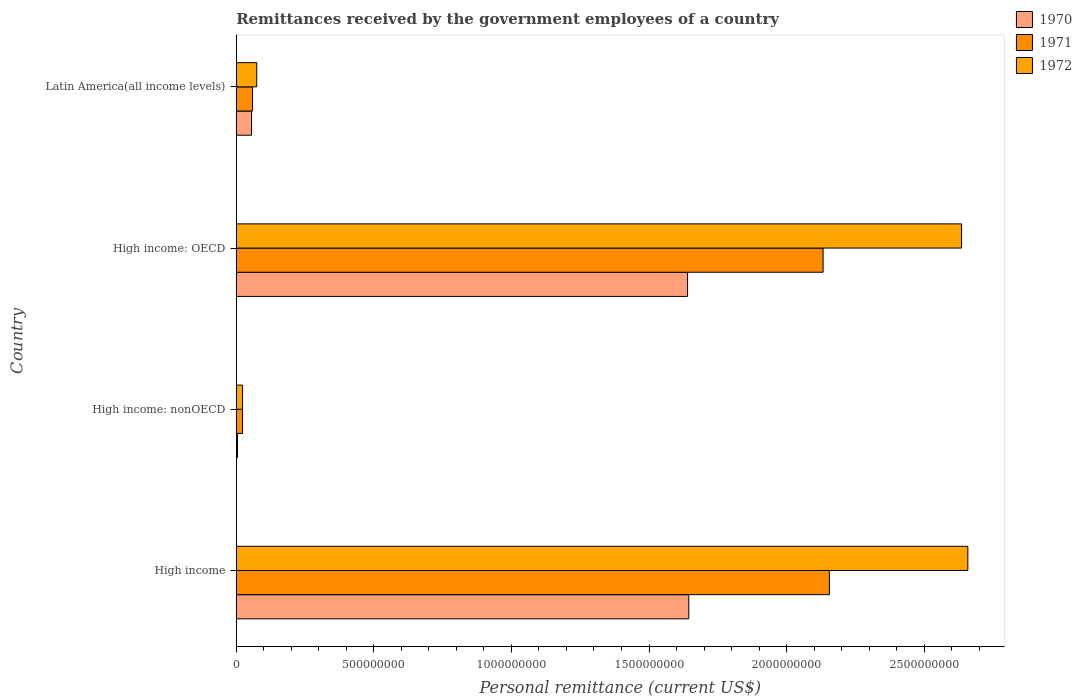How many different coloured bars are there?
Make the answer very short. 3. What is the label of the 2nd group of bars from the top?
Make the answer very short. High income: OECD. In how many cases, is the number of bars for a given country not equal to the number of legend labels?
Offer a terse response. 0. What is the remittances received by the government employees in 1972 in High income: OECD?
Ensure brevity in your answer.  2.64e+09. Across all countries, what is the maximum remittances received by the government employees in 1971?
Your answer should be compact. 2.16e+09. Across all countries, what is the minimum remittances received by the government employees in 1970?
Your answer should be compact. 4.40e+06. In which country was the remittances received by the government employees in 1970 maximum?
Your response must be concise. High income. In which country was the remittances received by the government employees in 1970 minimum?
Your answer should be compact. High income: nonOECD. What is the total remittances received by the government employees in 1970 in the graph?
Offer a very short reply. 3.34e+09. What is the difference between the remittances received by the government employees in 1971 in High income: OECD and that in High income: nonOECD?
Keep it short and to the point. 2.11e+09. What is the difference between the remittances received by the government employees in 1971 in High income and the remittances received by the government employees in 1972 in High income: nonOECD?
Offer a very short reply. 2.13e+09. What is the average remittances received by the government employees in 1972 per country?
Your answer should be very brief. 1.35e+09. What is the difference between the remittances received by the government employees in 1971 and remittances received by the government employees in 1972 in Latin America(all income levels)?
Your response must be concise. -1.54e+07. In how many countries, is the remittances received by the government employees in 1970 greater than 1400000000 US$?
Offer a terse response. 2. What is the ratio of the remittances received by the government employees in 1972 in High income to that in Latin America(all income levels)?
Your answer should be compact. 35.7. Is the remittances received by the government employees in 1970 in High income: nonOECD less than that in Latin America(all income levels)?
Give a very brief answer. Yes. What is the difference between the highest and the second highest remittances received by the government employees in 1970?
Your answer should be compact. 4.40e+06. What is the difference between the highest and the lowest remittances received by the government employees in 1971?
Give a very brief answer. 2.13e+09. Is the sum of the remittances received by the government employees in 1972 in High income and Latin America(all income levels) greater than the maximum remittances received by the government employees in 1971 across all countries?
Your response must be concise. Yes. Are all the bars in the graph horizontal?
Your response must be concise. Yes. How many countries are there in the graph?
Your response must be concise. 4. Are the values on the major ticks of X-axis written in scientific E-notation?
Provide a succinct answer. No. Where does the legend appear in the graph?
Give a very brief answer. Top right. How many legend labels are there?
Provide a short and direct response. 3. What is the title of the graph?
Your answer should be very brief. Remittances received by the government employees of a country. What is the label or title of the X-axis?
Your answer should be very brief. Personal remittance (current US$). What is the label or title of the Y-axis?
Make the answer very short. Country. What is the Personal remittance (current US$) of 1970 in High income?
Ensure brevity in your answer.  1.64e+09. What is the Personal remittance (current US$) of 1971 in High income?
Make the answer very short. 2.16e+09. What is the Personal remittance (current US$) in 1972 in High income?
Your answer should be compact. 2.66e+09. What is the Personal remittance (current US$) in 1970 in High income: nonOECD?
Your answer should be very brief. 4.40e+06. What is the Personal remittance (current US$) in 1971 in High income: nonOECD?
Keep it short and to the point. 2.28e+07. What is the Personal remittance (current US$) in 1972 in High income: nonOECD?
Your answer should be compact. 2.29e+07. What is the Personal remittance (current US$) in 1970 in High income: OECD?
Your response must be concise. 1.64e+09. What is the Personal remittance (current US$) of 1971 in High income: OECD?
Offer a very short reply. 2.13e+09. What is the Personal remittance (current US$) in 1972 in High income: OECD?
Ensure brevity in your answer.  2.64e+09. What is the Personal remittance (current US$) of 1970 in Latin America(all income levels)?
Give a very brief answer. 5.55e+07. What is the Personal remittance (current US$) in 1971 in Latin America(all income levels)?
Your answer should be very brief. 5.91e+07. What is the Personal remittance (current US$) of 1972 in Latin America(all income levels)?
Offer a terse response. 7.45e+07. Across all countries, what is the maximum Personal remittance (current US$) in 1970?
Your answer should be very brief. 1.64e+09. Across all countries, what is the maximum Personal remittance (current US$) of 1971?
Provide a short and direct response. 2.16e+09. Across all countries, what is the maximum Personal remittance (current US$) in 1972?
Offer a very short reply. 2.66e+09. Across all countries, what is the minimum Personal remittance (current US$) of 1970?
Your answer should be very brief. 4.40e+06. Across all countries, what is the minimum Personal remittance (current US$) in 1971?
Ensure brevity in your answer.  2.28e+07. Across all countries, what is the minimum Personal remittance (current US$) in 1972?
Ensure brevity in your answer.  2.29e+07. What is the total Personal remittance (current US$) in 1970 in the graph?
Ensure brevity in your answer.  3.34e+09. What is the total Personal remittance (current US$) in 1971 in the graph?
Your response must be concise. 4.37e+09. What is the total Personal remittance (current US$) in 1972 in the graph?
Offer a terse response. 5.39e+09. What is the difference between the Personal remittance (current US$) in 1970 in High income and that in High income: nonOECD?
Ensure brevity in your answer.  1.64e+09. What is the difference between the Personal remittance (current US$) in 1971 in High income and that in High income: nonOECD?
Make the answer very short. 2.13e+09. What is the difference between the Personal remittance (current US$) in 1972 in High income and that in High income: nonOECD?
Provide a short and direct response. 2.64e+09. What is the difference between the Personal remittance (current US$) of 1970 in High income and that in High income: OECD?
Make the answer very short. 4.40e+06. What is the difference between the Personal remittance (current US$) of 1971 in High income and that in High income: OECD?
Offer a very short reply. 2.28e+07. What is the difference between the Personal remittance (current US$) in 1972 in High income and that in High income: OECD?
Your response must be concise. 2.29e+07. What is the difference between the Personal remittance (current US$) in 1970 in High income and that in Latin America(all income levels)?
Ensure brevity in your answer.  1.59e+09. What is the difference between the Personal remittance (current US$) of 1971 in High income and that in Latin America(all income levels)?
Offer a very short reply. 2.10e+09. What is the difference between the Personal remittance (current US$) in 1972 in High income and that in Latin America(all income levels)?
Provide a short and direct response. 2.58e+09. What is the difference between the Personal remittance (current US$) in 1970 in High income: nonOECD and that in High income: OECD?
Make the answer very short. -1.64e+09. What is the difference between the Personal remittance (current US$) in 1971 in High income: nonOECD and that in High income: OECD?
Make the answer very short. -2.11e+09. What is the difference between the Personal remittance (current US$) in 1972 in High income: nonOECD and that in High income: OECD?
Your response must be concise. -2.61e+09. What is the difference between the Personal remittance (current US$) of 1970 in High income: nonOECD and that in Latin America(all income levels)?
Provide a short and direct response. -5.11e+07. What is the difference between the Personal remittance (current US$) of 1971 in High income: nonOECD and that in Latin America(all income levels)?
Provide a short and direct response. -3.63e+07. What is the difference between the Personal remittance (current US$) of 1972 in High income: nonOECD and that in Latin America(all income levels)?
Offer a terse response. -5.16e+07. What is the difference between the Personal remittance (current US$) of 1970 in High income: OECD and that in Latin America(all income levels)?
Keep it short and to the point. 1.58e+09. What is the difference between the Personal remittance (current US$) in 1971 in High income: OECD and that in Latin America(all income levels)?
Ensure brevity in your answer.  2.07e+09. What is the difference between the Personal remittance (current US$) of 1972 in High income: OECD and that in Latin America(all income levels)?
Offer a very short reply. 2.56e+09. What is the difference between the Personal remittance (current US$) in 1970 in High income and the Personal remittance (current US$) in 1971 in High income: nonOECD?
Offer a very short reply. 1.62e+09. What is the difference between the Personal remittance (current US$) of 1970 in High income and the Personal remittance (current US$) of 1972 in High income: nonOECD?
Your response must be concise. 1.62e+09. What is the difference between the Personal remittance (current US$) in 1971 in High income and the Personal remittance (current US$) in 1972 in High income: nonOECD?
Provide a succinct answer. 2.13e+09. What is the difference between the Personal remittance (current US$) of 1970 in High income and the Personal remittance (current US$) of 1971 in High income: OECD?
Offer a terse response. -4.88e+08. What is the difference between the Personal remittance (current US$) of 1970 in High income and the Personal remittance (current US$) of 1972 in High income: OECD?
Your answer should be very brief. -9.91e+08. What is the difference between the Personal remittance (current US$) of 1971 in High income and the Personal remittance (current US$) of 1972 in High income: OECD?
Your answer should be compact. -4.80e+08. What is the difference between the Personal remittance (current US$) in 1970 in High income and the Personal remittance (current US$) in 1971 in Latin America(all income levels)?
Your answer should be compact. 1.59e+09. What is the difference between the Personal remittance (current US$) of 1970 in High income and the Personal remittance (current US$) of 1972 in Latin America(all income levels)?
Give a very brief answer. 1.57e+09. What is the difference between the Personal remittance (current US$) of 1971 in High income and the Personal remittance (current US$) of 1972 in Latin America(all income levels)?
Provide a short and direct response. 2.08e+09. What is the difference between the Personal remittance (current US$) in 1970 in High income: nonOECD and the Personal remittance (current US$) in 1971 in High income: OECD?
Your answer should be very brief. -2.13e+09. What is the difference between the Personal remittance (current US$) of 1970 in High income: nonOECD and the Personal remittance (current US$) of 1972 in High income: OECD?
Your answer should be compact. -2.63e+09. What is the difference between the Personal remittance (current US$) of 1971 in High income: nonOECD and the Personal remittance (current US$) of 1972 in High income: OECD?
Your response must be concise. -2.61e+09. What is the difference between the Personal remittance (current US$) of 1970 in High income: nonOECD and the Personal remittance (current US$) of 1971 in Latin America(all income levels)?
Make the answer very short. -5.47e+07. What is the difference between the Personal remittance (current US$) of 1970 in High income: nonOECD and the Personal remittance (current US$) of 1972 in Latin America(all income levels)?
Your answer should be compact. -7.01e+07. What is the difference between the Personal remittance (current US$) in 1971 in High income: nonOECD and the Personal remittance (current US$) in 1972 in Latin America(all income levels)?
Ensure brevity in your answer.  -5.17e+07. What is the difference between the Personal remittance (current US$) of 1970 in High income: OECD and the Personal remittance (current US$) of 1971 in Latin America(all income levels)?
Offer a very short reply. 1.58e+09. What is the difference between the Personal remittance (current US$) of 1970 in High income: OECD and the Personal remittance (current US$) of 1972 in Latin America(all income levels)?
Make the answer very short. 1.57e+09. What is the difference between the Personal remittance (current US$) of 1971 in High income: OECD and the Personal remittance (current US$) of 1972 in Latin America(all income levels)?
Your answer should be very brief. 2.06e+09. What is the average Personal remittance (current US$) of 1970 per country?
Your response must be concise. 8.36e+08. What is the average Personal remittance (current US$) of 1971 per country?
Ensure brevity in your answer.  1.09e+09. What is the average Personal remittance (current US$) of 1972 per country?
Provide a succinct answer. 1.35e+09. What is the difference between the Personal remittance (current US$) in 1970 and Personal remittance (current US$) in 1971 in High income?
Provide a short and direct response. -5.11e+08. What is the difference between the Personal remittance (current US$) in 1970 and Personal remittance (current US$) in 1972 in High income?
Your response must be concise. -1.01e+09. What is the difference between the Personal remittance (current US$) in 1971 and Personal remittance (current US$) in 1972 in High income?
Offer a very short reply. -5.03e+08. What is the difference between the Personal remittance (current US$) in 1970 and Personal remittance (current US$) in 1971 in High income: nonOECD?
Your response must be concise. -1.84e+07. What is the difference between the Personal remittance (current US$) in 1970 and Personal remittance (current US$) in 1972 in High income: nonOECD?
Keep it short and to the point. -1.85e+07. What is the difference between the Personal remittance (current US$) of 1971 and Personal remittance (current US$) of 1972 in High income: nonOECD?
Your answer should be very brief. -1.37e+05. What is the difference between the Personal remittance (current US$) in 1970 and Personal remittance (current US$) in 1971 in High income: OECD?
Make the answer very short. -4.92e+08. What is the difference between the Personal remittance (current US$) of 1970 and Personal remittance (current US$) of 1972 in High income: OECD?
Make the answer very short. -9.96e+08. What is the difference between the Personal remittance (current US$) in 1971 and Personal remittance (current US$) in 1972 in High income: OECD?
Make the answer very short. -5.03e+08. What is the difference between the Personal remittance (current US$) of 1970 and Personal remittance (current US$) of 1971 in Latin America(all income levels)?
Offer a terse response. -3.57e+06. What is the difference between the Personal remittance (current US$) in 1970 and Personal remittance (current US$) in 1972 in Latin America(all income levels)?
Keep it short and to the point. -1.90e+07. What is the difference between the Personal remittance (current US$) in 1971 and Personal remittance (current US$) in 1972 in Latin America(all income levels)?
Provide a short and direct response. -1.54e+07. What is the ratio of the Personal remittance (current US$) of 1970 in High income to that in High income: nonOECD?
Provide a short and direct response. 373.75. What is the ratio of the Personal remittance (current US$) in 1971 in High income to that in High income: nonOECD?
Offer a terse response. 94.6. What is the ratio of the Personal remittance (current US$) in 1972 in High income to that in High income: nonOECD?
Make the answer very short. 115.99. What is the ratio of the Personal remittance (current US$) in 1971 in High income to that in High income: OECD?
Your answer should be very brief. 1.01. What is the ratio of the Personal remittance (current US$) in 1972 in High income to that in High income: OECD?
Give a very brief answer. 1.01. What is the ratio of the Personal remittance (current US$) in 1970 in High income to that in Latin America(all income levels)?
Keep it short and to the point. 29.63. What is the ratio of the Personal remittance (current US$) of 1971 in High income to that in Latin America(all income levels)?
Provide a succinct answer. 36.49. What is the ratio of the Personal remittance (current US$) of 1972 in High income to that in Latin America(all income levels)?
Your answer should be compact. 35.7. What is the ratio of the Personal remittance (current US$) of 1970 in High income: nonOECD to that in High income: OECD?
Offer a very short reply. 0. What is the ratio of the Personal remittance (current US$) in 1971 in High income: nonOECD to that in High income: OECD?
Give a very brief answer. 0.01. What is the ratio of the Personal remittance (current US$) of 1972 in High income: nonOECD to that in High income: OECD?
Offer a very short reply. 0.01. What is the ratio of the Personal remittance (current US$) in 1970 in High income: nonOECD to that in Latin America(all income levels)?
Ensure brevity in your answer.  0.08. What is the ratio of the Personal remittance (current US$) in 1971 in High income: nonOECD to that in Latin America(all income levels)?
Make the answer very short. 0.39. What is the ratio of the Personal remittance (current US$) in 1972 in High income: nonOECD to that in Latin America(all income levels)?
Offer a terse response. 0.31. What is the ratio of the Personal remittance (current US$) of 1970 in High income: OECD to that in Latin America(all income levels)?
Your answer should be very brief. 29.55. What is the ratio of the Personal remittance (current US$) of 1971 in High income: OECD to that in Latin America(all income levels)?
Provide a short and direct response. 36.1. What is the ratio of the Personal remittance (current US$) of 1972 in High income: OECD to that in Latin America(all income levels)?
Provide a succinct answer. 35.39. What is the difference between the highest and the second highest Personal remittance (current US$) of 1970?
Your answer should be compact. 4.40e+06. What is the difference between the highest and the second highest Personal remittance (current US$) of 1971?
Offer a very short reply. 2.28e+07. What is the difference between the highest and the second highest Personal remittance (current US$) of 1972?
Keep it short and to the point. 2.29e+07. What is the difference between the highest and the lowest Personal remittance (current US$) of 1970?
Offer a terse response. 1.64e+09. What is the difference between the highest and the lowest Personal remittance (current US$) of 1971?
Offer a very short reply. 2.13e+09. What is the difference between the highest and the lowest Personal remittance (current US$) in 1972?
Offer a very short reply. 2.64e+09. 